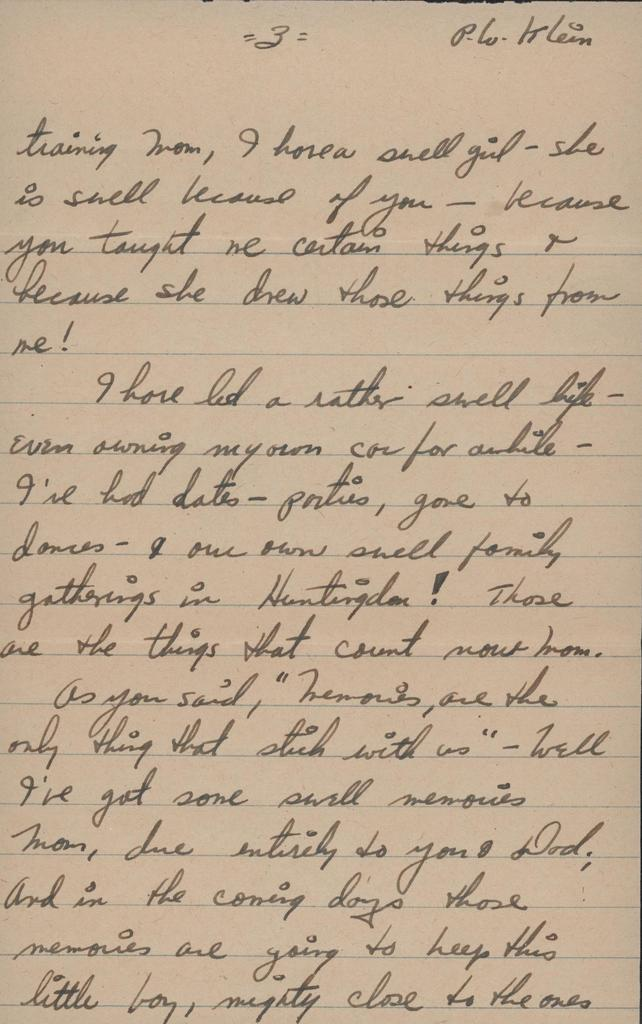<image>
Present a compact description of the photo's key features. A hand written letter that starts by saying Training mom. 